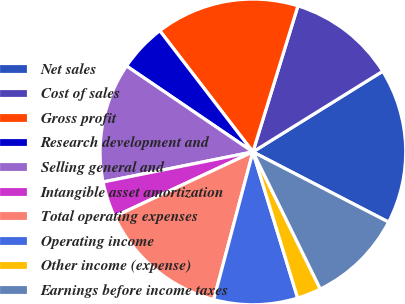Convert chart to OTSL. <chart><loc_0><loc_0><loc_500><loc_500><pie_chart><fcel>Net sales<fcel>Cost of sales<fcel>Gross profit<fcel>Research development and<fcel>Selling general and<fcel>Intangible asset amortization<fcel>Total operating expenses<fcel>Operating income<fcel>Other income (expense)<fcel>Earnings before income taxes<nl><fcel>16.45%<fcel>11.39%<fcel>15.19%<fcel>5.07%<fcel>12.66%<fcel>3.8%<fcel>13.92%<fcel>8.86%<fcel>2.54%<fcel>10.13%<nl></chart> 